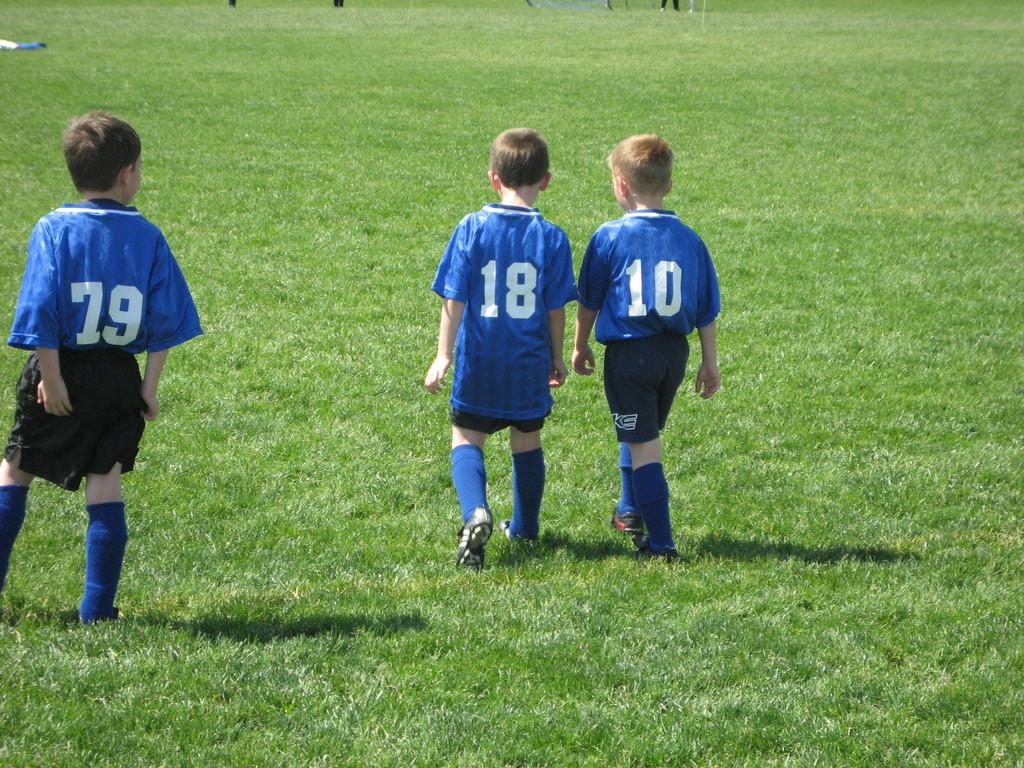How many kids are present in the image? There are three kids in the image. What are the kids doing in the image? The kids are walking on the grass. What is the weight of the swing in the image? There is no swing present in the image, so it is not possible to determine its weight. 